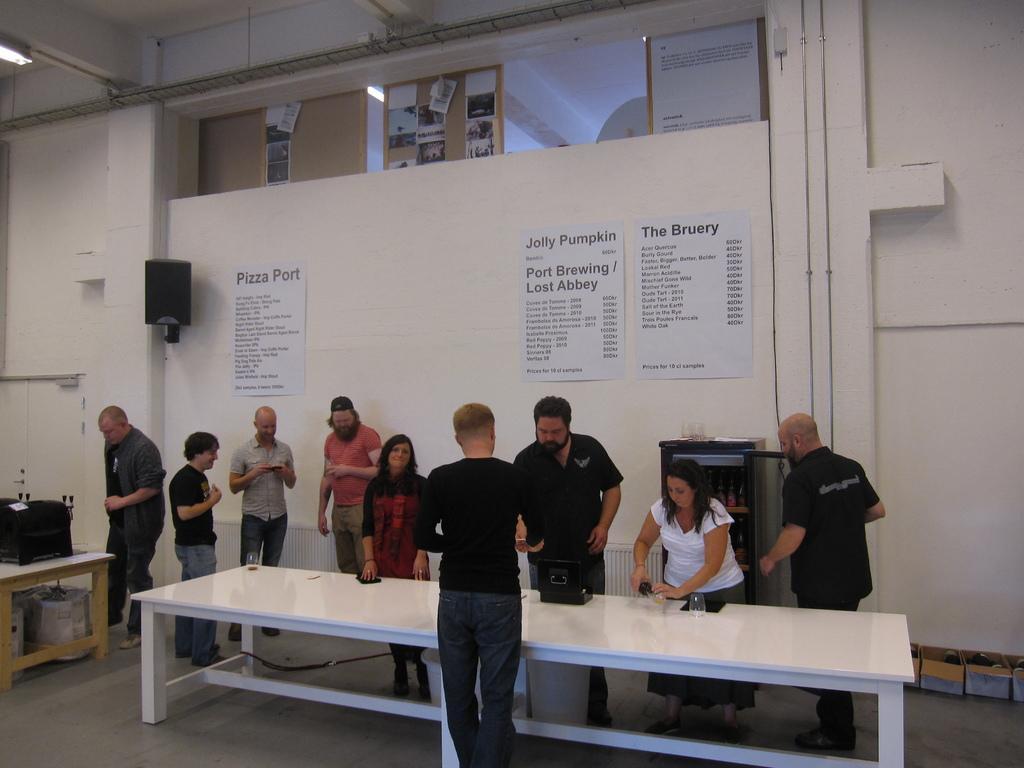Describe this image in one or two sentences. In this image i can see group of people standing there are few glasses on a table at the back ground i can see few papers attached to a wall and a woofer. 